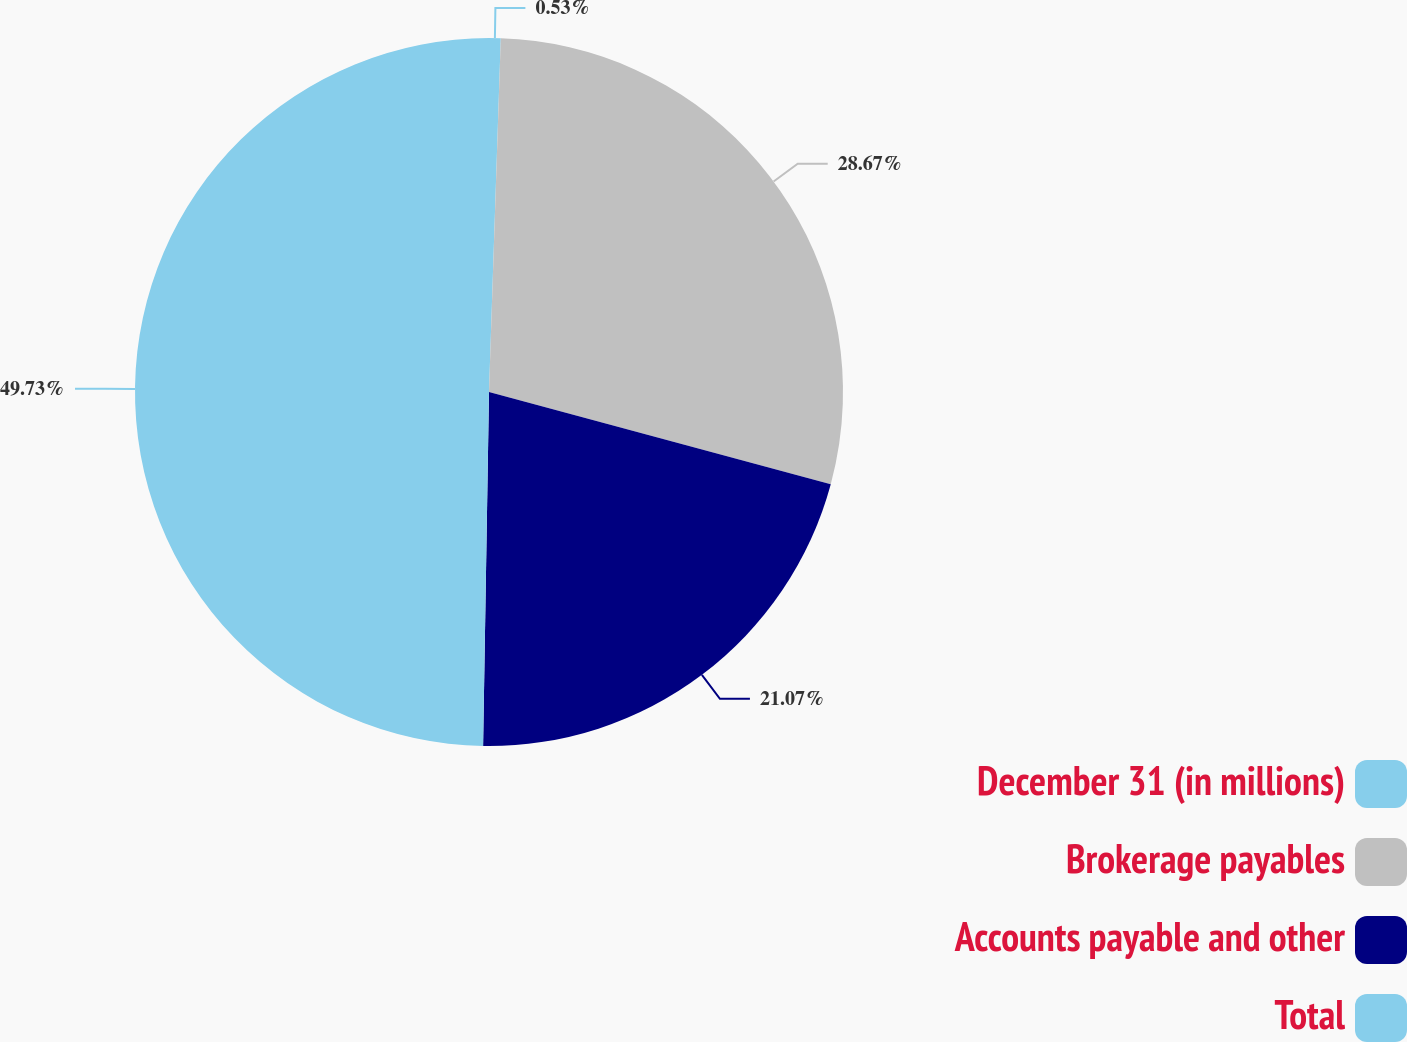Convert chart to OTSL. <chart><loc_0><loc_0><loc_500><loc_500><pie_chart><fcel>December 31 (in millions)<fcel>Brokerage payables<fcel>Accounts payable and other<fcel>Total<nl><fcel>0.53%<fcel>28.67%<fcel>21.07%<fcel>49.74%<nl></chart> 